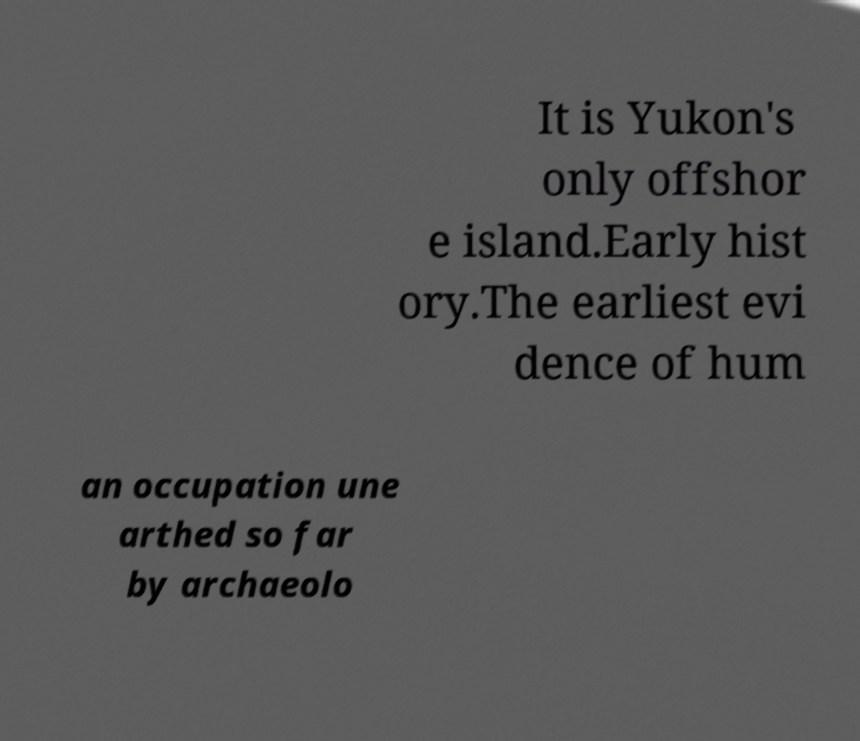Can you accurately transcribe the text from the provided image for me? It is Yukon's only offshor e island.Early hist ory.The earliest evi dence of hum an occupation une arthed so far by archaeolo 